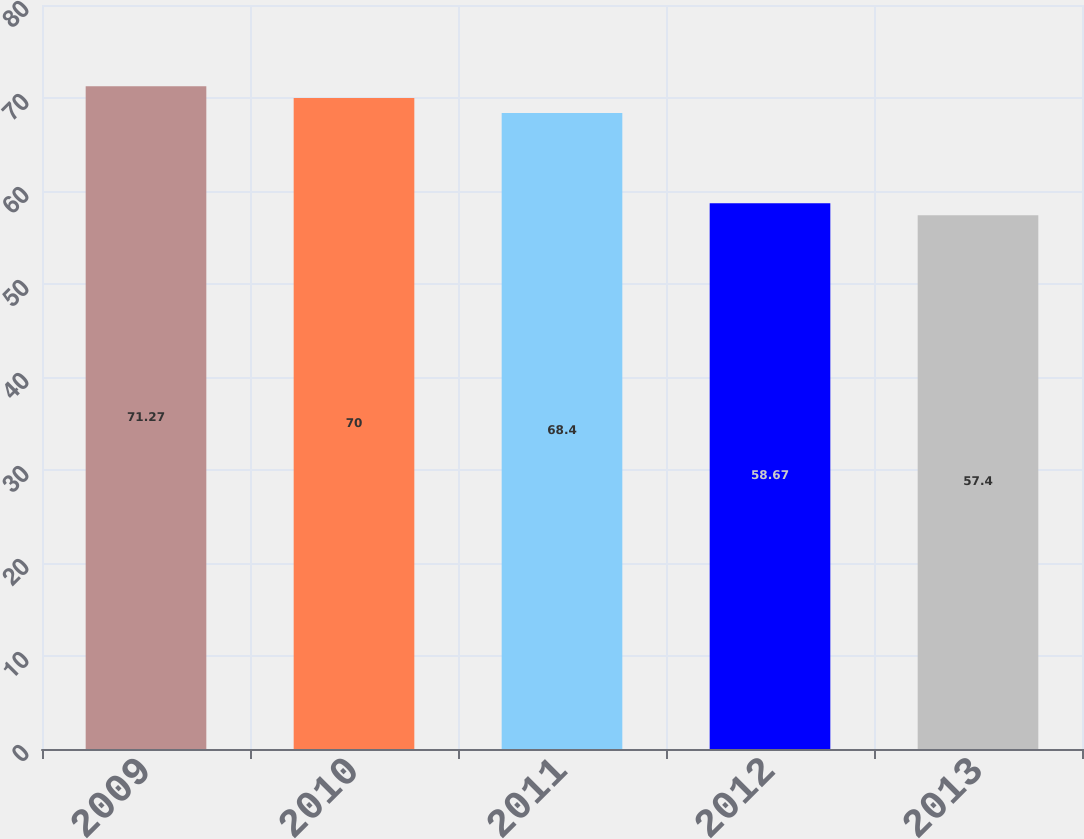Convert chart. <chart><loc_0><loc_0><loc_500><loc_500><bar_chart><fcel>2009<fcel>2010<fcel>2011<fcel>2012<fcel>2013<nl><fcel>71.27<fcel>70<fcel>68.4<fcel>58.67<fcel>57.4<nl></chart> 